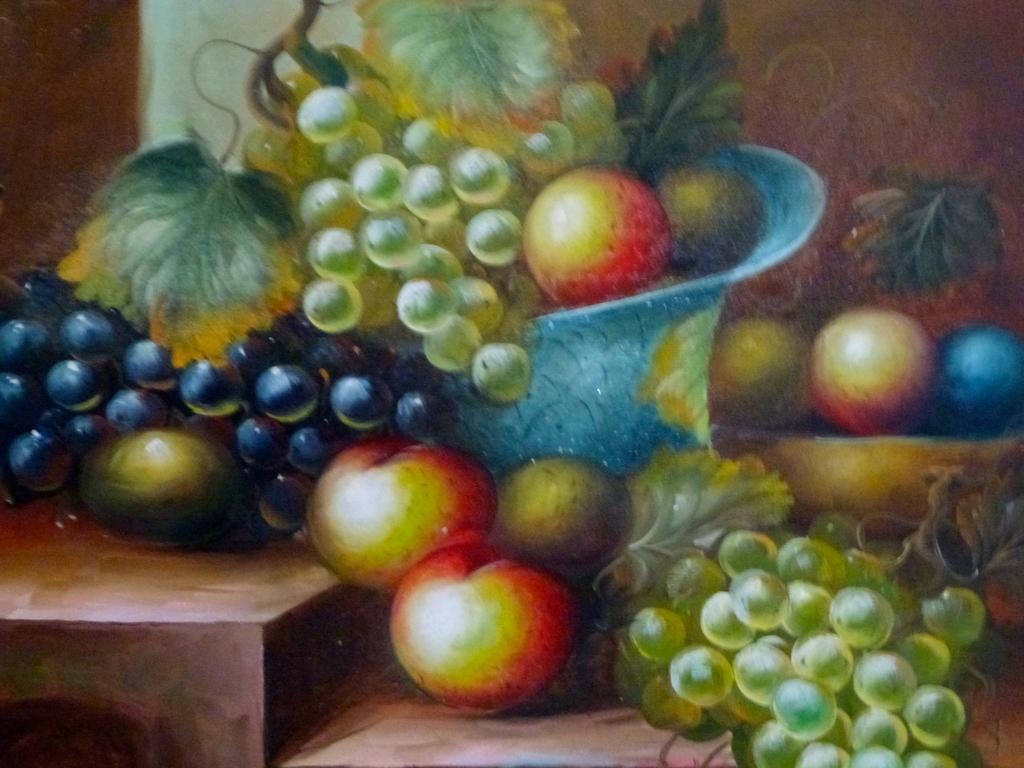What is the main subject of the art in the image? The main subject of the art in the image is grapes. What type of objects are depicted in the art? Fruits are depicted in the art. What note is being played by the grapes in the image? There are no musical instruments or notes present in the image; it features an art of grapes and fruits. 